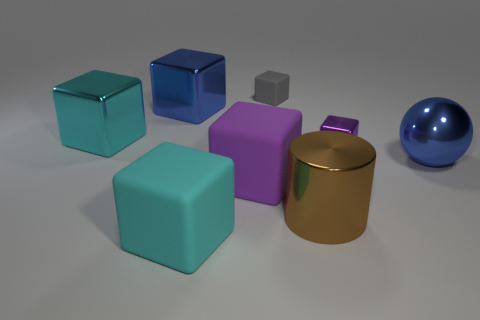Subtract all purple shiny blocks. How many blocks are left? 5 Subtract all cyan blocks. How many blocks are left? 4 Subtract all yellow blocks. Subtract all blue balls. How many blocks are left? 6 Add 2 small purple objects. How many objects exist? 10 Subtract all cubes. How many objects are left? 2 Add 6 gray blocks. How many gray blocks exist? 7 Subtract 0 gray balls. How many objects are left? 8 Subtract all large brown metallic balls. Subtract all large rubber cubes. How many objects are left? 6 Add 3 gray blocks. How many gray blocks are left? 4 